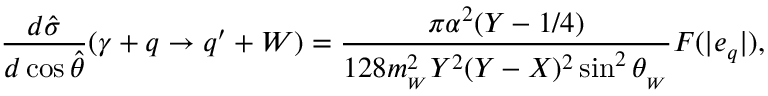Convert formula to latex. <formula><loc_0><loc_0><loc_500><loc_500>\frac { d \hat { \sigma } } { d \cos \hat { \theta } } ( \gamma + q \rightarrow q ^ { \prime } + W ) = \frac { \pi \alpha ^ { 2 } ( Y - 1 / 4 ) } { 1 2 8 m _ { _ { W } } ^ { 2 } Y ^ { 2 } ( Y - X ) ^ { 2 } \sin ^ { 2 } \theta _ { _ { W } } } F ( | e _ { q } | ) ,</formula> 